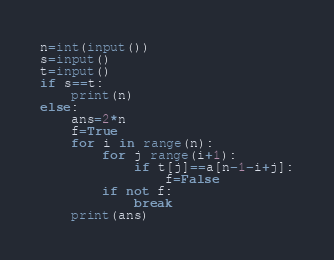<code> <loc_0><loc_0><loc_500><loc_500><_Python_>n=int(input())
s=input()
t=input()
if s==t:
    print(n)
else:
    ans=2*n
    f=True
    for i in range(n):
        for j range(i+1):
            if t[j]==a[n-1-i+j]:
                f=False
        if not f:
            break
    print(ans)</code> 